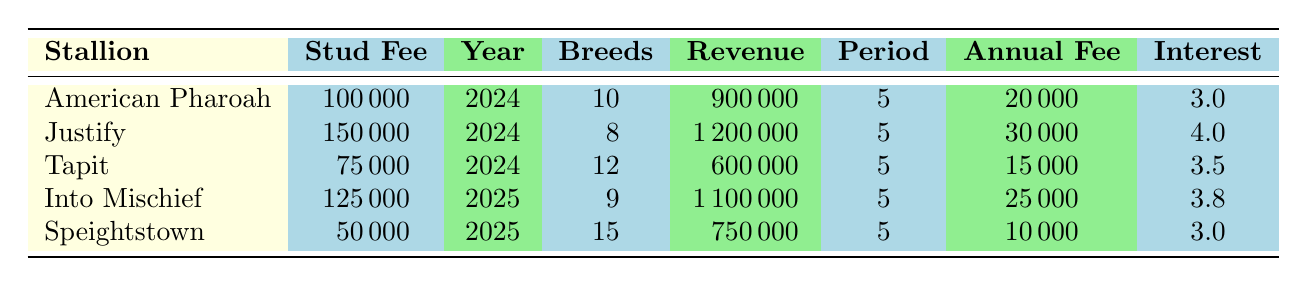What is the stud fee for Justify? The table indicates that the stud fee for Justify is listed directly in the corresponding row under the "Stud Fee" column.
Answer: 150000 How many breeds does Tapit offer? The number of breeds for Tapit is found in the "Breeds" column, which shows a value of 12.
Answer: 12 Which stallion has the highest total revenue? By examining the "Revenue" column for all stallions, Justify has the highest value of 1200000.
Answer: Justify What is the average annual fee across all stallions? First, sum the annual fees: 20000 + 30000 + 15000 + 25000 + 10000 = 100000. Then, divide by the number of stallions (5): 100000 / 5 = 20000.
Answer: 20000 Is the stud fee for Speightstown less than 60000? Looking at the "Stud Fee" column, Speightstown's fee is 50000, which is indeed less than 60000.
Answer: Yes How much total revenue would be earned from all breeds of American Pharoah? The total revenue for American Pharoah is already provided in the table as 900000, corresponding to the number of breeds he has (10).
Answer: 900000 Which stallion has the lowest interest rate? Upon checking the "Interest" column, both Speightstown and American Pharoah have the same lowest interest rate of 3.0.
Answer: Speightstown and American Pharoah How much more revenue does Justify generate compared to Tapit? First, we identify the revenue for Justify (1200000) and Tapit (600000). Then subtract Tapit's revenue from Justify's: 1200000 - 600000 = 600000.
Answer: 600000 What is the total stud fee for all stallions listed? We add up the stud fees: 100000 + 150000 + 75000 + 125000 + 50000 = 500000.
Answer: 500000 